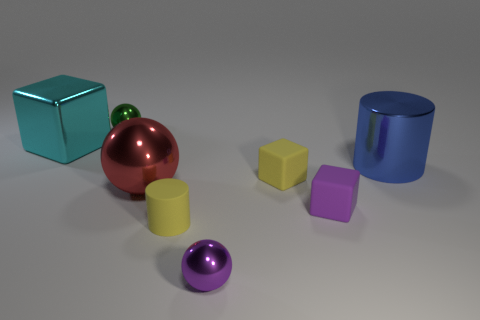Is there any indication of light source direction based on the shadows of the objects? Yes, the shadows of the objects suggest that the light source is coming from the upper left-hand side of the image. Each object casts a shadow angled towards the bottom right, which means that the light is hitting them from a diagonal direction, slightly from above. 